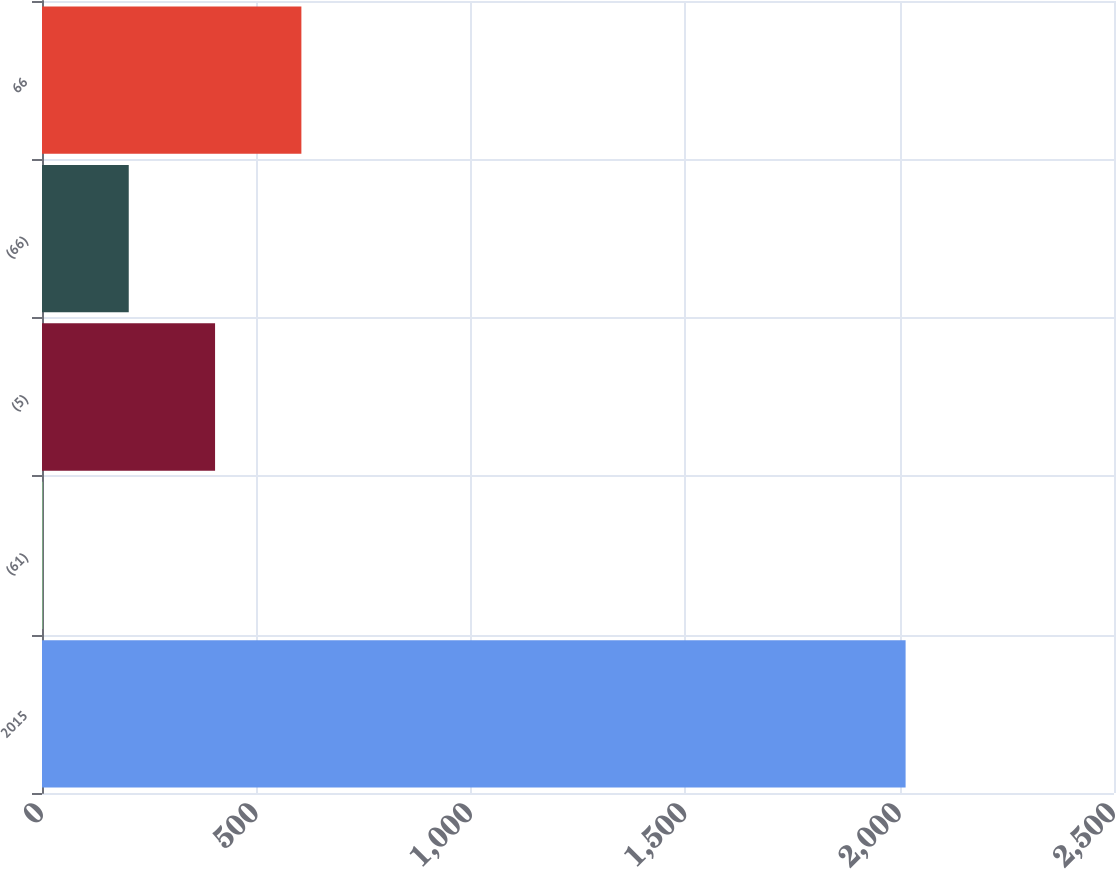Convert chart. <chart><loc_0><loc_0><loc_500><loc_500><bar_chart><fcel>2015<fcel>(61)<fcel>(5)<fcel>(66)<fcel>66<nl><fcel>2014<fcel>1<fcel>403.6<fcel>202.3<fcel>604.9<nl></chart> 